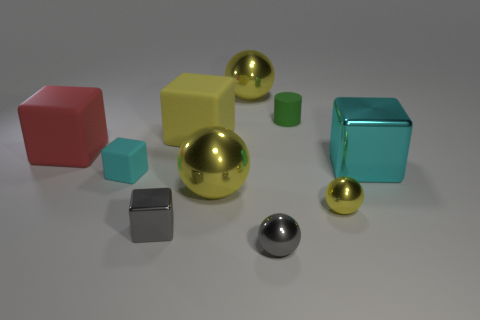Is the number of rubber objects less than the number of metal blocks?
Offer a terse response. No. There is a matte block that is both right of the red matte thing and behind the big cyan object; what is its size?
Your response must be concise. Large. There is a shiny cube that is in front of the metallic block on the right side of the large thing that is behind the tiny green thing; how big is it?
Give a very brief answer. Small. What size is the yellow matte object?
Offer a terse response. Large. Are there any other things that have the same material as the gray block?
Make the answer very short. Yes. There is a ball that is behind the tiny rubber thing behind the cyan metallic thing; is there a cyan rubber block behind it?
Offer a very short reply. No. What number of tiny objects are either yellow cubes or spheres?
Give a very brief answer. 2. Are there any other things that have the same color as the small matte cube?
Provide a short and direct response. Yes. Does the yellow shiny ball that is on the right side of the green rubber thing have the same size as the cyan shiny block?
Offer a terse response. No. What is the color of the tiny object that is to the left of the metallic thing that is left of the big yellow shiny sphere in front of the cyan rubber block?
Offer a terse response. Cyan. 